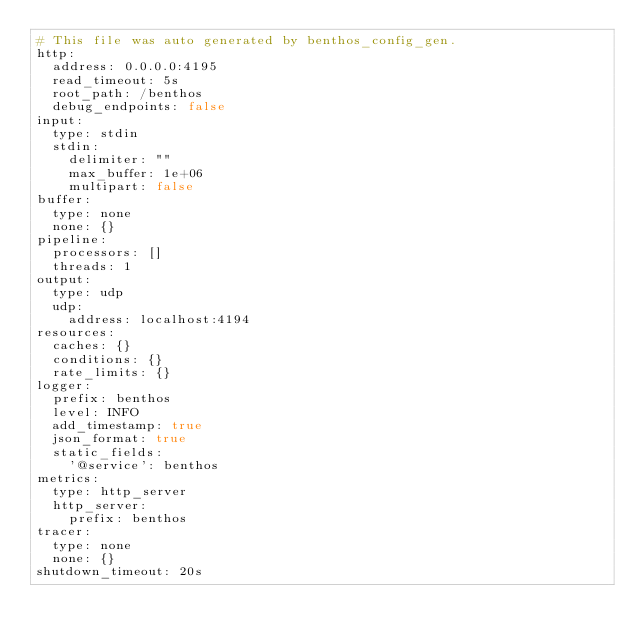<code> <loc_0><loc_0><loc_500><loc_500><_YAML_># This file was auto generated by benthos_config_gen.
http:
  address: 0.0.0.0:4195
  read_timeout: 5s
  root_path: /benthos
  debug_endpoints: false
input:
  type: stdin
  stdin:
    delimiter: ""
    max_buffer: 1e+06
    multipart: false
buffer:
  type: none
  none: {}
pipeline:
  processors: []
  threads: 1
output:
  type: udp
  udp:
    address: localhost:4194
resources:
  caches: {}
  conditions: {}
  rate_limits: {}
logger:
  prefix: benthos
  level: INFO
  add_timestamp: true
  json_format: true
  static_fields:
    '@service': benthos
metrics:
  type: http_server
  http_server:
    prefix: benthos
tracer:
  type: none
  none: {}
shutdown_timeout: 20s
</code> 